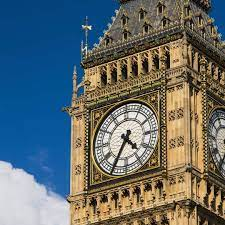How does Big Ben's clock mechanism work? Big Ben's clock mechanism is a marvel of 19th-century engineering. It's a large four-faced chiming clock located at the top of the tower, driven by a pendulum and weights that travel down a shaft. The clock mechanism, which has undergone several upgrades, ensures remarkable precision. Its pendulum is regulated by a stack of coins and an old penny is added or removed to fine-tune its timekeeping. Is there anything unique about the clock's design? Definitely! The clock faces are set in an iron frame and consist of 312 pieces of opal glass, similar to a stained-glass window. Each dial measures about 23 feet in diameter. Unique to the design, at each quarter, the figures of Justice, Temperance, Fortitude, and Prudence are seen with the Latin inscription 'DOMINE SALVAM FAC REGINAM NOSTRAM VICTORIAM PRIMAM,' which means 'Lord, keep safe our Queen Victoria the First.' 